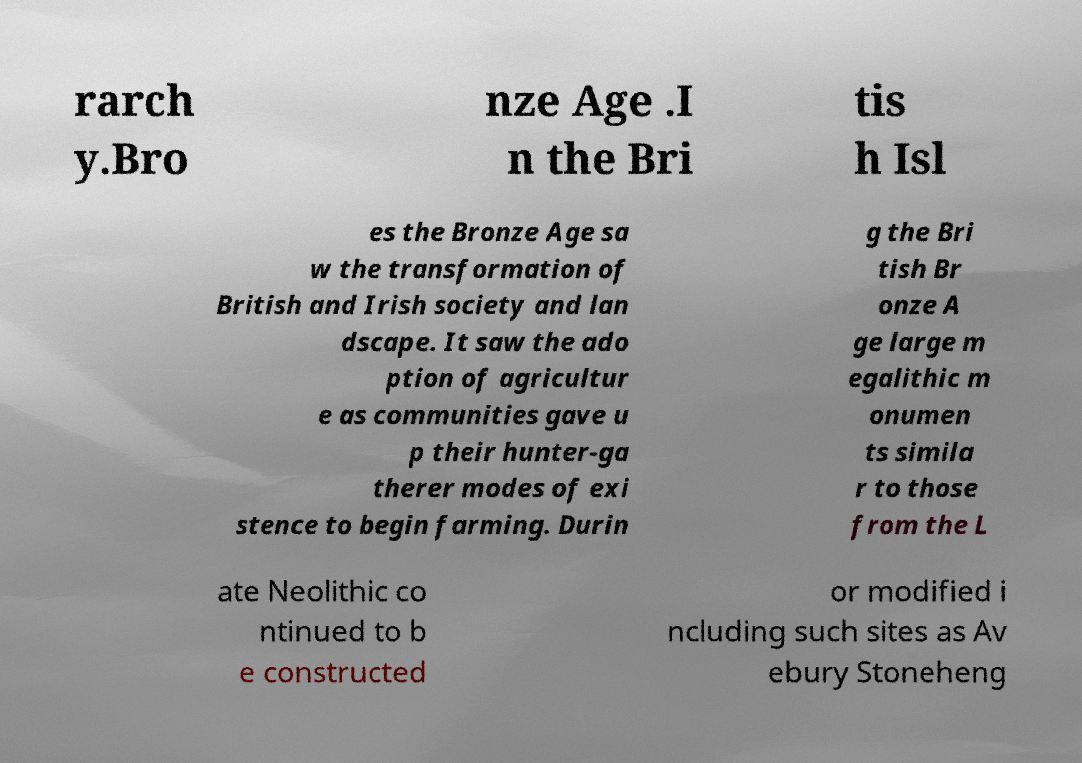What messages or text are displayed in this image? I need them in a readable, typed format. rarch y.Bro nze Age .I n the Bri tis h Isl es the Bronze Age sa w the transformation of British and Irish society and lan dscape. It saw the ado ption of agricultur e as communities gave u p their hunter-ga therer modes of exi stence to begin farming. Durin g the Bri tish Br onze A ge large m egalithic m onumen ts simila r to those from the L ate Neolithic co ntinued to b e constructed or modified i ncluding such sites as Av ebury Stoneheng 